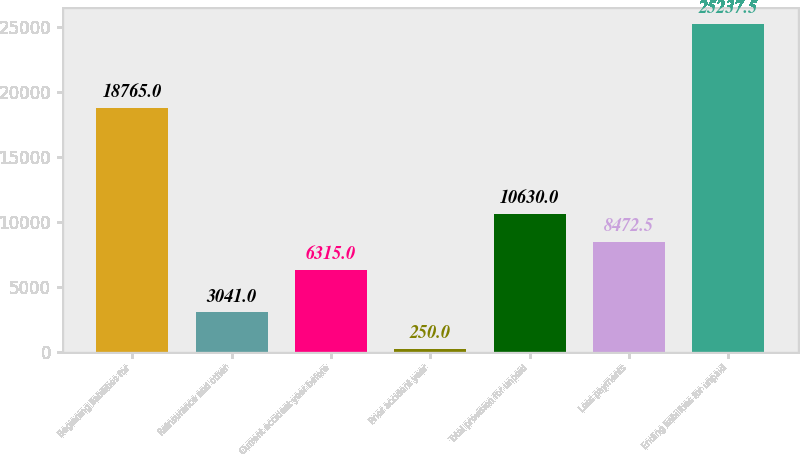Convert chart to OTSL. <chart><loc_0><loc_0><loc_500><loc_500><bar_chart><fcel>Beginning liabilities for<fcel>Reinsurance and other<fcel>Current accident year before<fcel>Prior accident year<fcel>Total provision for unpaid<fcel>Less payments<fcel>Ending liabilities for unpaid<nl><fcel>18765<fcel>3041<fcel>6315<fcel>250<fcel>10630<fcel>8472.5<fcel>25237.5<nl></chart> 